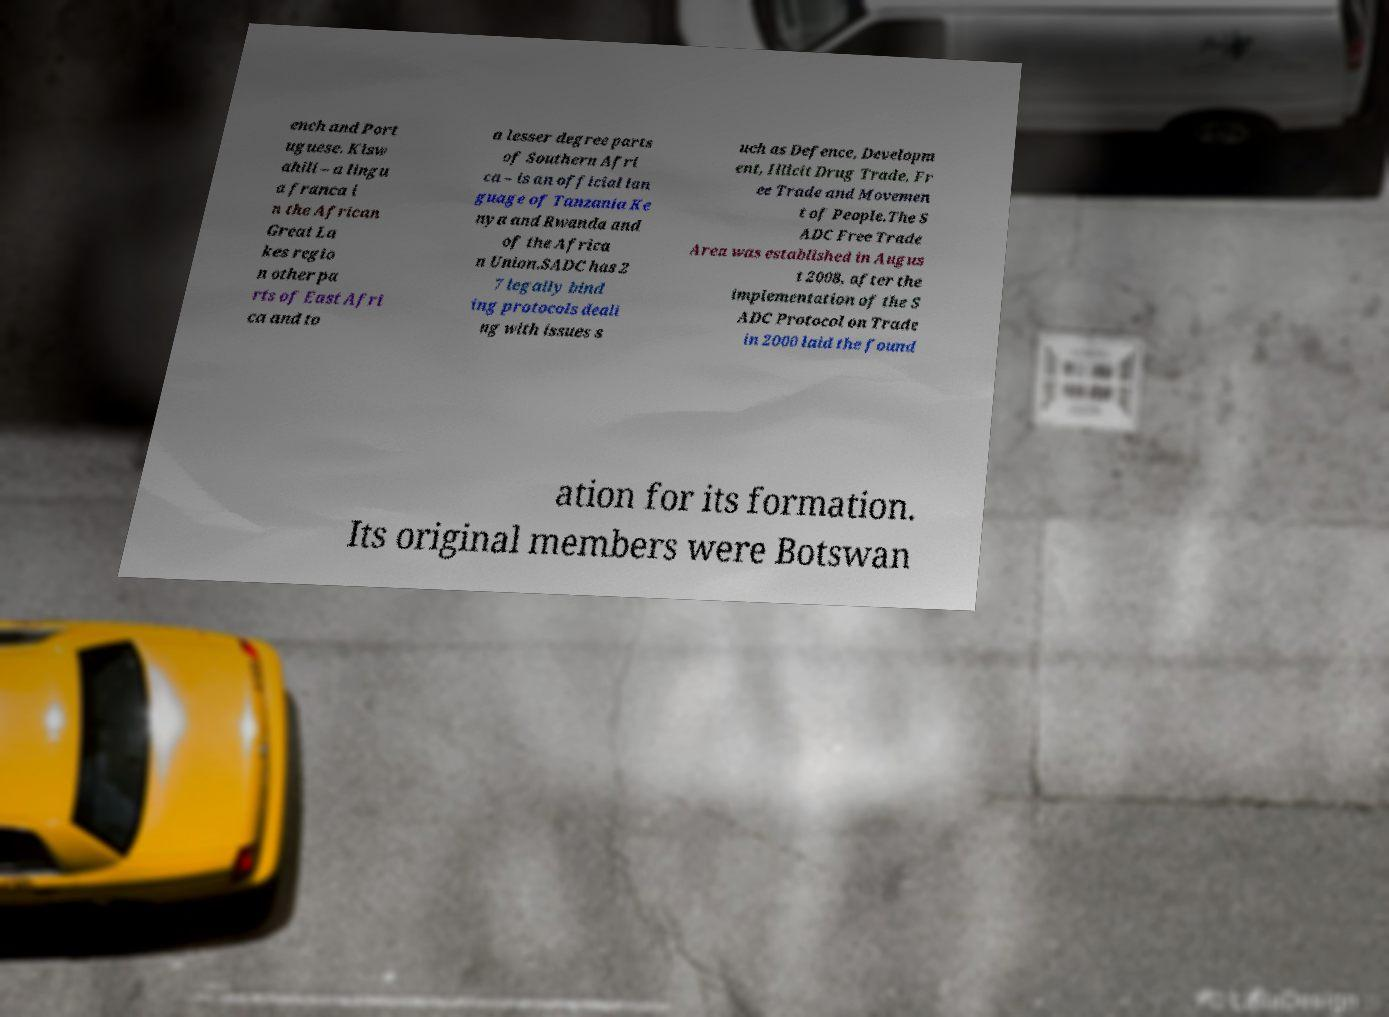Can you accurately transcribe the text from the provided image for me? ench and Port uguese. Kisw ahili – a lingu a franca i n the African Great La kes regio n other pa rts of East Afri ca and to a lesser degree parts of Southern Afri ca – is an official lan guage of Tanzania Ke nya and Rwanda and of the Africa n Union.SADC has 2 7 legally bind ing protocols deali ng with issues s uch as Defence, Developm ent, Illicit Drug Trade, Fr ee Trade and Movemen t of People.The S ADC Free Trade Area was established in Augus t 2008, after the implementation of the S ADC Protocol on Trade in 2000 laid the found ation for its formation. Its original members were Botswan 